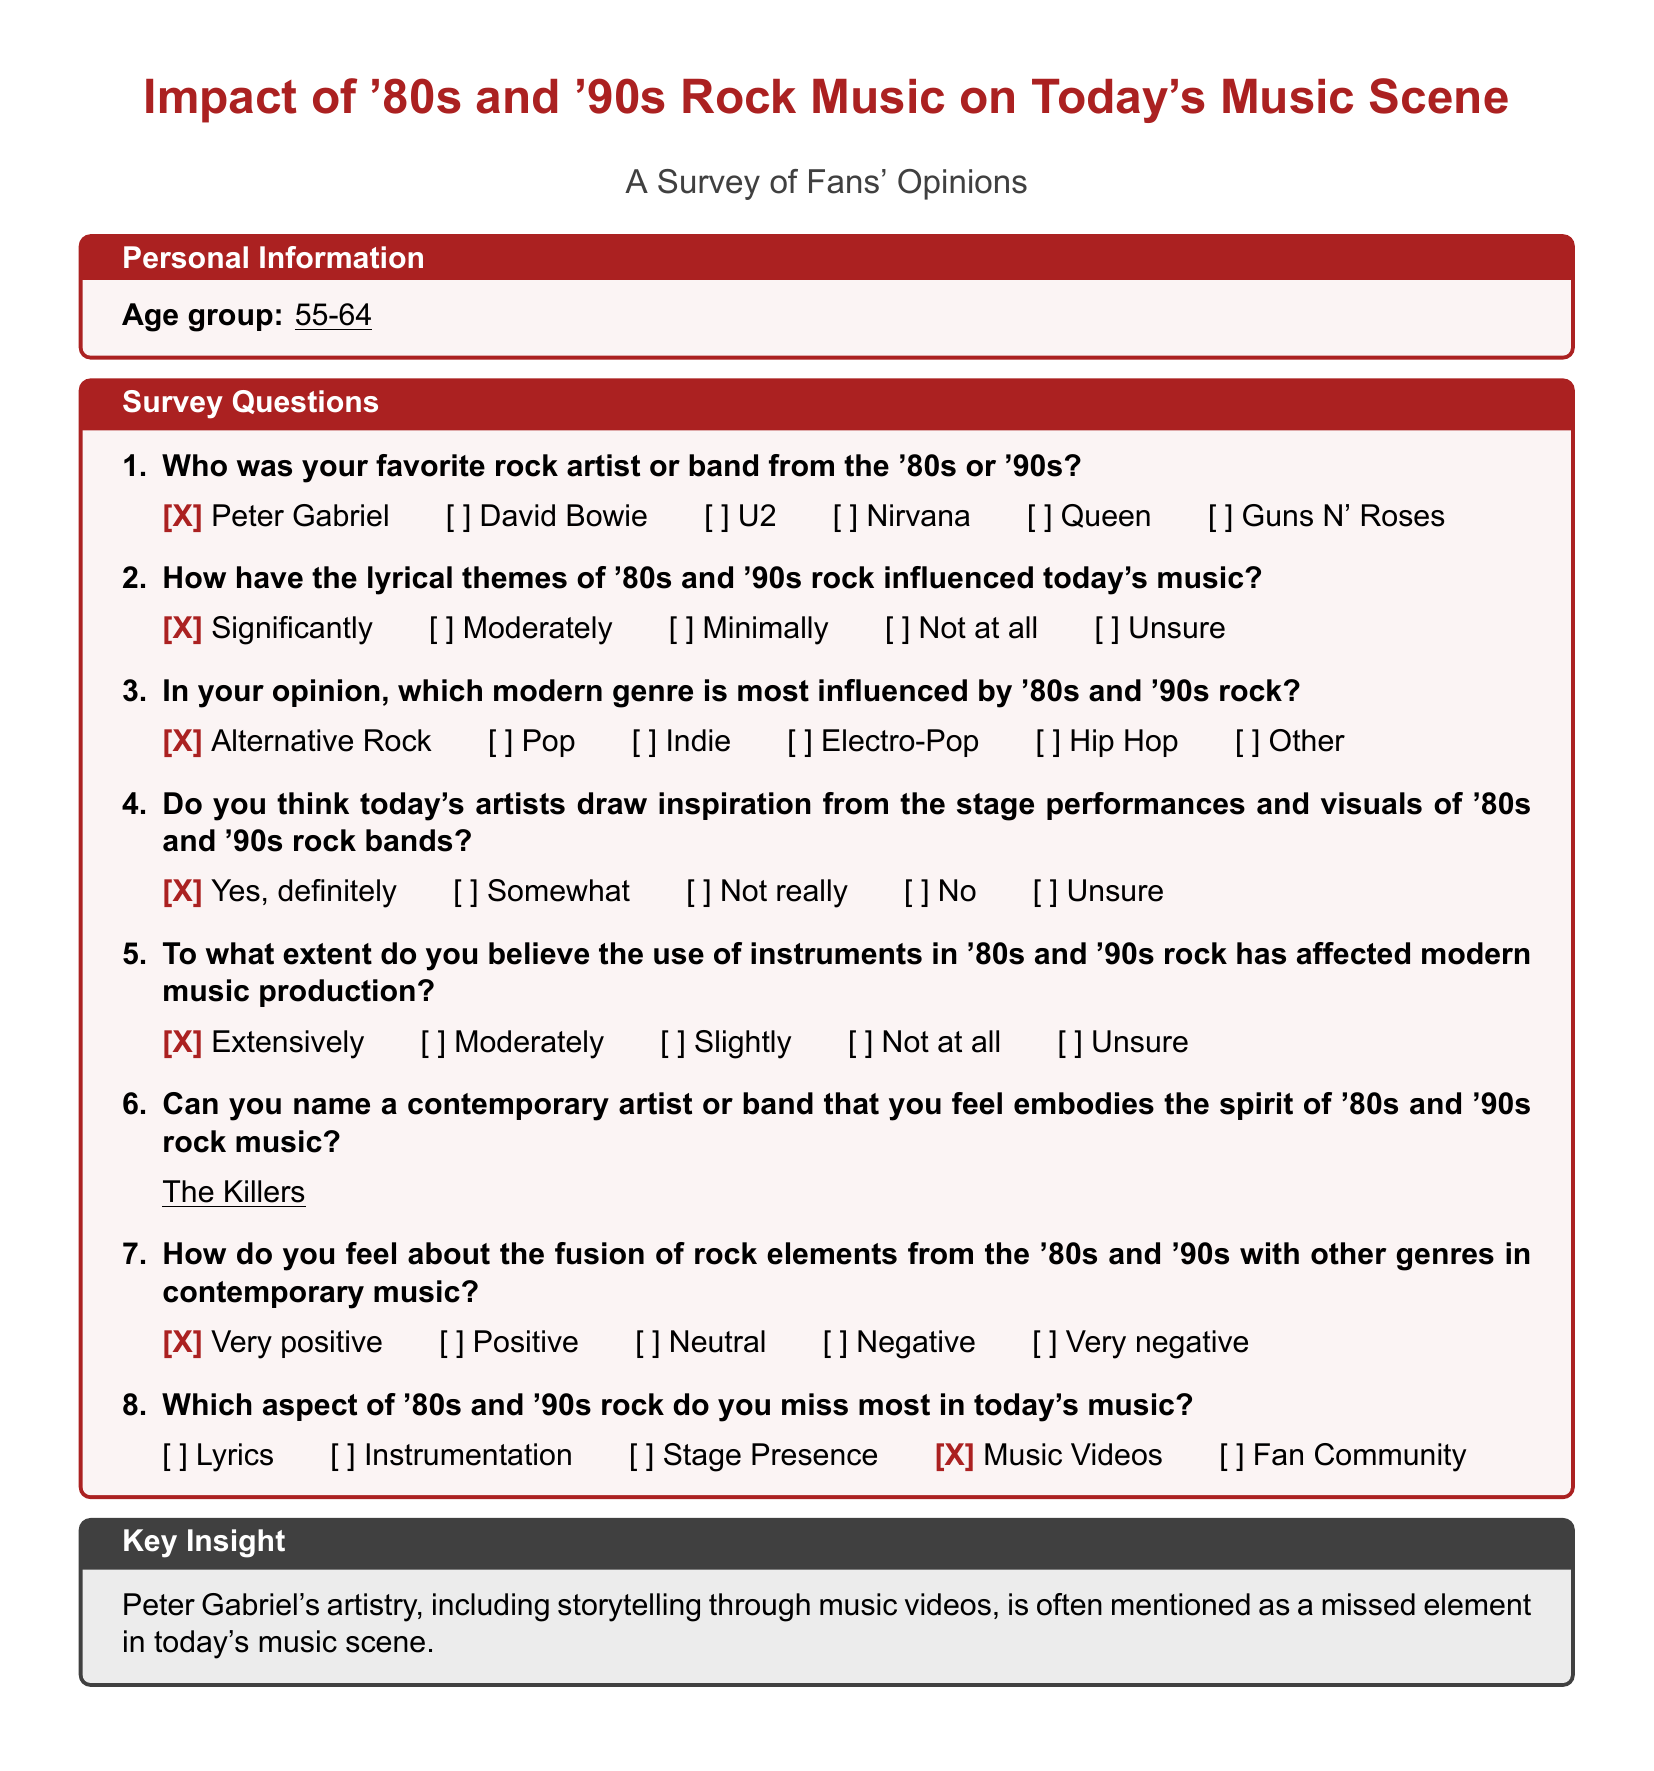Who was the favorite rock artist from the '80s or '90s? The favorite rock artist checked in the survey is Peter Gabriel.
Answer: Peter Gabriel How have the lyrical themes of '80s and '90s rock influenced today's music? The survey indicates a significant influence according to the response selected.
Answer: Significantly Which modern genre is most influenced by '80s and '90s rock? The survey response shows that Alternative Rock is identified as the most influenced genre.
Answer: Alternative Rock Do today's artists draw inspiration from '80s and '90s rock performances? The answer checked confirms a strong belief that today's artists definitely draw inspiration.
Answer: Yes, definitely What contemporary artist embodies the spirit of '80s and '90s rock music? The survey lists The Killers as a contemporary artist that embodies that spirit.
Answer: The Killers What aspect of '80s and '90s rock is most missed in today's music? The response indicates a preference for missing music videos the most.
Answer: Music Videos To what extent do the instruments of '80s and '90s rock affect modern music production? The selected answer indicates that they affect modern music production extensively.
Answer: Extensively 